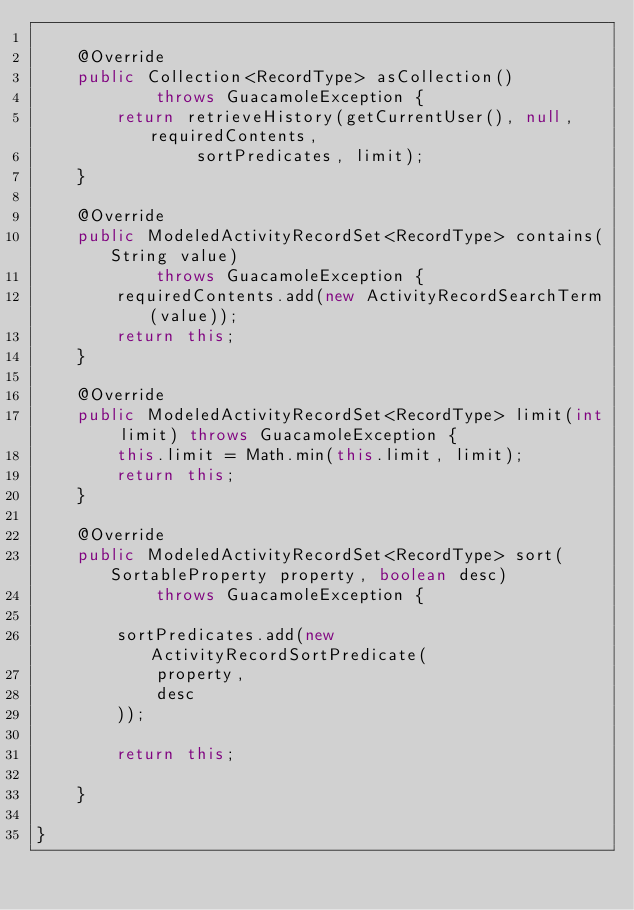<code> <loc_0><loc_0><loc_500><loc_500><_Java_>
    @Override
    public Collection<RecordType> asCollection()
            throws GuacamoleException {
        return retrieveHistory(getCurrentUser(), null, requiredContents,
                sortPredicates, limit);
    }

    @Override
    public ModeledActivityRecordSet<RecordType> contains(String value)
            throws GuacamoleException {
        requiredContents.add(new ActivityRecordSearchTerm(value));
        return this;
    }

    @Override
    public ModeledActivityRecordSet<RecordType> limit(int limit) throws GuacamoleException {
        this.limit = Math.min(this.limit, limit);
        return this;
    }

    @Override
    public ModeledActivityRecordSet<RecordType> sort(SortableProperty property, boolean desc)
            throws GuacamoleException {
        
        sortPredicates.add(new ActivityRecordSortPredicate(
            property,
            desc
        ));
        
        return this;

    }

}
</code> 